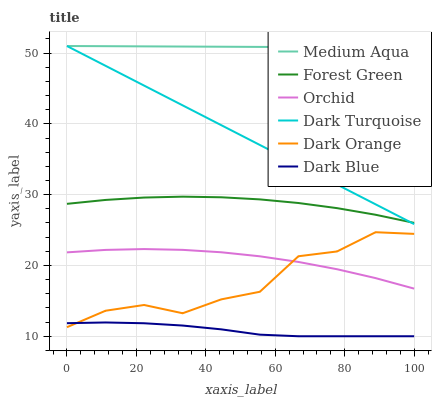Does Dark Blue have the minimum area under the curve?
Answer yes or no. Yes. Does Medium Aqua have the maximum area under the curve?
Answer yes or no. Yes. Does Dark Turquoise have the minimum area under the curve?
Answer yes or no. No. Does Dark Turquoise have the maximum area under the curve?
Answer yes or no. No. Is Medium Aqua the smoothest?
Answer yes or no. Yes. Is Dark Orange the roughest?
Answer yes or no. Yes. Is Dark Turquoise the smoothest?
Answer yes or no. No. Is Dark Turquoise the roughest?
Answer yes or no. No. Does Dark Blue have the lowest value?
Answer yes or no. Yes. Does Dark Turquoise have the lowest value?
Answer yes or no. No. Does Medium Aqua have the highest value?
Answer yes or no. Yes. Does Dark Blue have the highest value?
Answer yes or no. No. Is Forest Green less than Medium Aqua?
Answer yes or no. Yes. Is Forest Green greater than Orchid?
Answer yes or no. Yes. Does Orchid intersect Dark Orange?
Answer yes or no. Yes. Is Orchid less than Dark Orange?
Answer yes or no. No. Is Orchid greater than Dark Orange?
Answer yes or no. No. Does Forest Green intersect Medium Aqua?
Answer yes or no. No. 